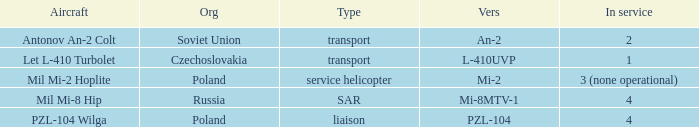Tell me the origin for mi-2 Poland. 